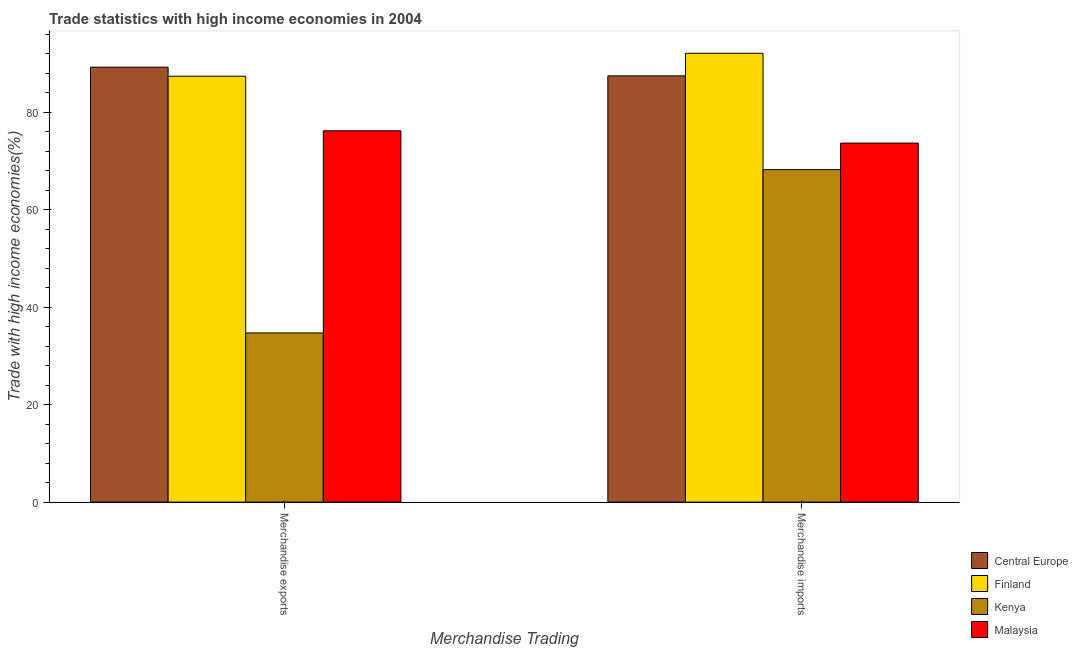How many groups of bars are there?
Ensure brevity in your answer.  2. How many bars are there on the 1st tick from the left?
Offer a terse response. 4. What is the label of the 2nd group of bars from the left?
Offer a very short reply. Merchandise imports. What is the merchandise exports in Central Europe?
Ensure brevity in your answer.  89.27. Across all countries, what is the maximum merchandise exports?
Offer a very short reply. 89.27. Across all countries, what is the minimum merchandise exports?
Give a very brief answer. 34.72. In which country was the merchandise exports maximum?
Your answer should be compact. Central Europe. In which country was the merchandise exports minimum?
Give a very brief answer. Kenya. What is the total merchandise exports in the graph?
Offer a very short reply. 287.63. What is the difference between the merchandise exports in Malaysia and that in Central Europe?
Give a very brief answer. -13.06. What is the difference between the merchandise exports in Finland and the merchandise imports in Kenya?
Give a very brief answer. 19.17. What is the average merchandise imports per country?
Your answer should be compact. 80.39. What is the difference between the merchandise exports and merchandise imports in Finland?
Your answer should be very brief. -4.71. What is the ratio of the merchandise imports in Finland to that in Malaysia?
Keep it short and to the point. 1.25. Is the merchandise imports in Finland less than that in Kenya?
Your response must be concise. No. What does the 1st bar from the right in Merchandise exports represents?
Offer a terse response. Malaysia. How many bars are there?
Your answer should be compact. 8. How many countries are there in the graph?
Your answer should be very brief. 4. Does the graph contain any zero values?
Your answer should be compact. No. Where does the legend appear in the graph?
Your answer should be compact. Bottom right. How many legend labels are there?
Offer a very short reply. 4. How are the legend labels stacked?
Give a very brief answer. Vertical. What is the title of the graph?
Your answer should be very brief. Trade statistics with high income economies in 2004. What is the label or title of the X-axis?
Your response must be concise. Merchandise Trading. What is the label or title of the Y-axis?
Make the answer very short. Trade with high income economies(%). What is the Trade with high income economies(%) of Central Europe in Merchandise exports?
Offer a very short reply. 89.27. What is the Trade with high income economies(%) of Finland in Merchandise exports?
Ensure brevity in your answer.  87.42. What is the Trade with high income economies(%) of Kenya in Merchandise exports?
Your answer should be compact. 34.72. What is the Trade with high income economies(%) in Malaysia in Merchandise exports?
Provide a succinct answer. 76.22. What is the Trade with high income economies(%) in Central Europe in Merchandise imports?
Provide a short and direct response. 87.49. What is the Trade with high income economies(%) of Finland in Merchandise imports?
Make the answer very short. 92.13. What is the Trade with high income economies(%) of Kenya in Merchandise imports?
Provide a short and direct response. 68.24. What is the Trade with high income economies(%) in Malaysia in Merchandise imports?
Ensure brevity in your answer.  73.69. Across all Merchandise Trading, what is the maximum Trade with high income economies(%) in Central Europe?
Make the answer very short. 89.27. Across all Merchandise Trading, what is the maximum Trade with high income economies(%) of Finland?
Your answer should be very brief. 92.13. Across all Merchandise Trading, what is the maximum Trade with high income economies(%) of Kenya?
Ensure brevity in your answer.  68.24. Across all Merchandise Trading, what is the maximum Trade with high income economies(%) in Malaysia?
Ensure brevity in your answer.  76.22. Across all Merchandise Trading, what is the minimum Trade with high income economies(%) in Central Europe?
Your answer should be compact. 87.49. Across all Merchandise Trading, what is the minimum Trade with high income economies(%) of Finland?
Your answer should be very brief. 87.42. Across all Merchandise Trading, what is the minimum Trade with high income economies(%) of Kenya?
Ensure brevity in your answer.  34.72. Across all Merchandise Trading, what is the minimum Trade with high income economies(%) in Malaysia?
Provide a succinct answer. 73.69. What is the total Trade with high income economies(%) of Central Europe in the graph?
Offer a very short reply. 176.77. What is the total Trade with high income economies(%) in Finland in the graph?
Offer a terse response. 179.54. What is the total Trade with high income economies(%) of Kenya in the graph?
Provide a succinct answer. 102.97. What is the total Trade with high income economies(%) in Malaysia in the graph?
Keep it short and to the point. 149.91. What is the difference between the Trade with high income economies(%) in Central Europe in Merchandise exports and that in Merchandise imports?
Make the answer very short. 1.78. What is the difference between the Trade with high income economies(%) in Finland in Merchandise exports and that in Merchandise imports?
Offer a terse response. -4.71. What is the difference between the Trade with high income economies(%) of Kenya in Merchandise exports and that in Merchandise imports?
Your response must be concise. -33.52. What is the difference between the Trade with high income economies(%) of Malaysia in Merchandise exports and that in Merchandise imports?
Your answer should be very brief. 2.52. What is the difference between the Trade with high income economies(%) in Central Europe in Merchandise exports and the Trade with high income economies(%) in Finland in Merchandise imports?
Your answer should be very brief. -2.85. What is the difference between the Trade with high income economies(%) of Central Europe in Merchandise exports and the Trade with high income economies(%) of Kenya in Merchandise imports?
Offer a very short reply. 21.03. What is the difference between the Trade with high income economies(%) of Central Europe in Merchandise exports and the Trade with high income economies(%) of Malaysia in Merchandise imports?
Provide a succinct answer. 15.58. What is the difference between the Trade with high income economies(%) of Finland in Merchandise exports and the Trade with high income economies(%) of Kenya in Merchandise imports?
Your answer should be very brief. 19.17. What is the difference between the Trade with high income economies(%) of Finland in Merchandise exports and the Trade with high income economies(%) of Malaysia in Merchandise imports?
Provide a short and direct response. 13.72. What is the difference between the Trade with high income economies(%) of Kenya in Merchandise exports and the Trade with high income economies(%) of Malaysia in Merchandise imports?
Give a very brief answer. -38.97. What is the average Trade with high income economies(%) of Central Europe per Merchandise Trading?
Your answer should be very brief. 88.38. What is the average Trade with high income economies(%) of Finland per Merchandise Trading?
Give a very brief answer. 89.77. What is the average Trade with high income economies(%) in Kenya per Merchandise Trading?
Offer a terse response. 51.48. What is the average Trade with high income economies(%) in Malaysia per Merchandise Trading?
Provide a succinct answer. 74.95. What is the difference between the Trade with high income economies(%) in Central Europe and Trade with high income economies(%) in Finland in Merchandise exports?
Give a very brief answer. 1.86. What is the difference between the Trade with high income economies(%) of Central Europe and Trade with high income economies(%) of Kenya in Merchandise exports?
Your answer should be compact. 54.55. What is the difference between the Trade with high income economies(%) in Central Europe and Trade with high income economies(%) in Malaysia in Merchandise exports?
Your answer should be very brief. 13.06. What is the difference between the Trade with high income economies(%) of Finland and Trade with high income economies(%) of Kenya in Merchandise exports?
Offer a terse response. 52.69. What is the difference between the Trade with high income economies(%) of Finland and Trade with high income economies(%) of Malaysia in Merchandise exports?
Your answer should be very brief. 11.2. What is the difference between the Trade with high income economies(%) of Kenya and Trade with high income economies(%) of Malaysia in Merchandise exports?
Provide a short and direct response. -41.49. What is the difference between the Trade with high income economies(%) in Central Europe and Trade with high income economies(%) in Finland in Merchandise imports?
Your answer should be compact. -4.64. What is the difference between the Trade with high income economies(%) of Central Europe and Trade with high income economies(%) of Kenya in Merchandise imports?
Provide a short and direct response. 19.25. What is the difference between the Trade with high income economies(%) in Central Europe and Trade with high income economies(%) in Malaysia in Merchandise imports?
Keep it short and to the point. 13.8. What is the difference between the Trade with high income economies(%) in Finland and Trade with high income economies(%) in Kenya in Merchandise imports?
Provide a short and direct response. 23.88. What is the difference between the Trade with high income economies(%) in Finland and Trade with high income economies(%) in Malaysia in Merchandise imports?
Your answer should be compact. 18.43. What is the difference between the Trade with high income economies(%) in Kenya and Trade with high income economies(%) in Malaysia in Merchandise imports?
Ensure brevity in your answer.  -5.45. What is the ratio of the Trade with high income economies(%) in Central Europe in Merchandise exports to that in Merchandise imports?
Offer a terse response. 1.02. What is the ratio of the Trade with high income economies(%) in Finland in Merchandise exports to that in Merchandise imports?
Give a very brief answer. 0.95. What is the ratio of the Trade with high income economies(%) of Kenya in Merchandise exports to that in Merchandise imports?
Provide a succinct answer. 0.51. What is the ratio of the Trade with high income economies(%) in Malaysia in Merchandise exports to that in Merchandise imports?
Make the answer very short. 1.03. What is the difference between the highest and the second highest Trade with high income economies(%) in Central Europe?
Your response must be concise. 1.78. What is the difference between the highest and the second highest Trade with high income economies(%) in Finland?
Your answer should be compact. 4.71. What is the difference between the highest and the second highest Trade with high income economies(%) in Kenya?
Your answer should be very brief. 33.52. What is the difference between the highest and the second highest Trade with high income economies(%) of Malaysia?
Offer a very short reply. 2.52. What is the difference between the highest and the lowest Trade with high income economies(%) of Central Europe?
Offer a terse response. 1.78. What is the difference between the highest and the lowest Trade with high income economies(%) of Finland?
Your answer should be compact. 4.71. What is the difference between the highest and the lowest Trade with high income economies(%) of Kenya?
Keep it short and to the point. 33.52. What is the difference between the highest and the lowest Trade with high income economies(%) of Malaysia?
Your answer should be compact. 2.52. 